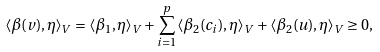Convert formula to latex. <formula><loc_0><loc_0><loc_500><loc_500>\langle \beta ( v ) , \eta \rangle _ { V } = \langle \beta _ { 1 } , \eta \rangle _ { V } + \sum _ { i = 1 } ^ { p } \langle \beta _ { 2 } ( c _ { i } ) , \eta \rangle _ { V } + \langle \beta _ { 2 } ( u ) , \eta \rangle _ { V } \geq 0 ,</formula> 